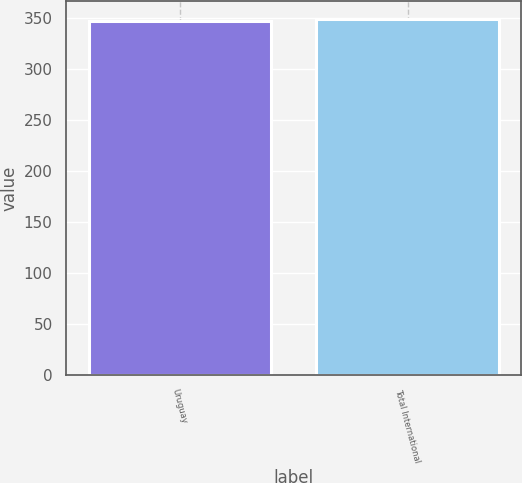Convert chart to OTSL. <chart><loc_0><loc_0><loc_500><loc_500><bar_chart><fcel>Uruguay<fcel>Total International<nl><fcel>347<fcel>349<nl></chart> 